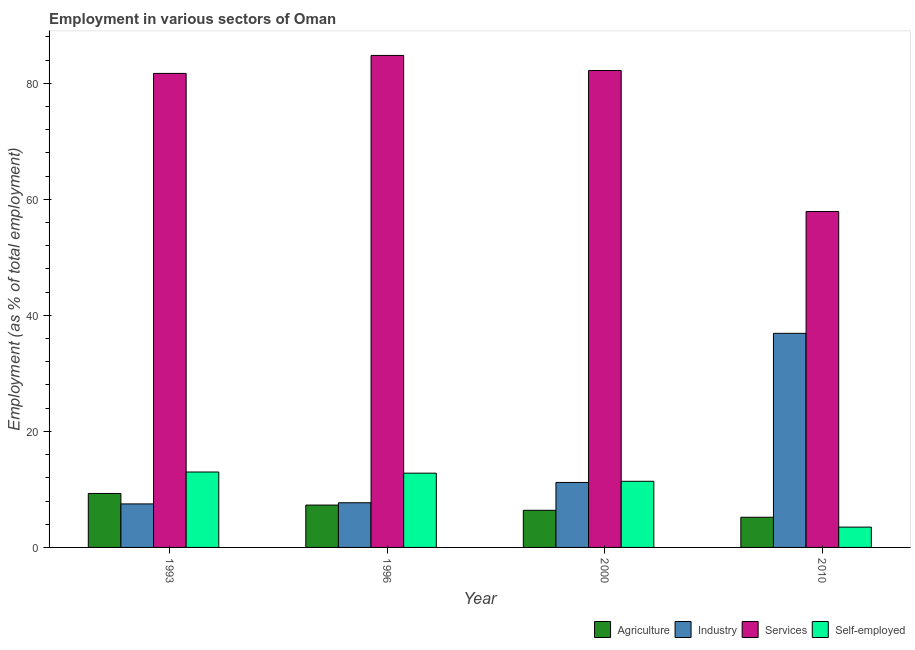Are the number of bars on each tick of the X-axis equal?
Offer a terse response. Yes. In how many cases, is the number of bars for a given year not equal to the number of legend labels?
Provide a succinct answer. 0. What is the percentage of self employed workers in 2010?
Ensure brevity in your answer.  3.5. Across all years, what is the minimum percentage of workers in agriculture?
Keep it short and to the point. 5.2. In which year was the percentage of self employed workers maximum?
Your answer should be very brief. 1993. What is the total percentage of workers in agriculture in the graph?
Give a very brief answer. 28.2. What is the difference between the percentage of workers in agriculture in 2000 and that in 2010?
Offer a terse response. 1.2. What is the difference between the percentage of workers in services in 2010 and the percentage of workers in agriculture in 2000?
Your response must be concise. -24.3. What is the average percentage of self employed workers per year?
Provide a succinct answer. 10.17. In how many years, is the percentage of self employed workers greater than 12 %?
Provide a succinct answer. 2. What is the ratio of the percentage of self employed workers in 1996 to that in 2000?
Give a very brief answer. 1.12. Is the percentage of workers in industry in 1996 less than that in 2000?
Your answer should be compact. Yes. Is the difference between the percentage of workers in agriculture in 1996 and 2000 greater than the difference between the percentage of workers in services in 1996 and 2000?
Offer a terse response. No. What is the difference between the highest and the second highest percentage of workers in services?
Offer a terse response. 2.6. What is the difference between the highest and the lowest percentage of self employed workers?
Give a very brief answer. 9.5. In how many years, is the percentage of workers in industry greater than the average percentage of workers in industry taken over all years?
Your answer should be compact. 1. Is the sum of the percentage of workers in industry in 1996 and 2000 greater than the maximum percentage of workers in agriculture across all years?
Offer a very short reply. No. Is it the case that in every year, the sum of the percentage of workers in agriculture and percentage of workers in services is greater than the sum of percentage of workers in industry and percentage of self employed workers?
Make the answer very short. No. What does the 3rd bar from the left in 2010 represents?
Provide a succinct answer. Services. What does the 4th bar from the right in 1993 represents?
Your answer should be compact. Agriculture. Does the graph contain grids?
Ensure brevity in your answer.  No. Where does the legend appear in the graph?
Make the answer very short. Bottom right. How many legend labels are there?
Ensure brevity in your answer.  4. How are the legend labels stacked?
Keep it short and to the point. Horizontal. What is the title of the graph?
Your answer should be compact. Employment in various sectors of Oman. What is the label or title of the X-axis?
Give a very brief answer. Year. What is the label or title of the Y-axis?
Keep it short and to the point. Employment (as % of total employment). What is the Employment (as % of total employment) of Agriculture in 1993?
Offer a very short reply. 9.3. What is the Employment (as % of total employment) in Industry in 1993?
Offer a terse response. 7.5. What is the Employment (as % of total employment) of Services in 1993?
Your response must be concise. 81.7. What is the Employment (as % of total employment) in Agriculture in 1996?
Your answer should be very brief. 7.3. What is the Employment (as % of total employment) of Industry in 1996?
Offer a terse response. 7.7. What is the Employment (as % of total employment) of Services in 1996?
Offer a very short reply. 84.8. What is the Employment (as % of total employment) in Self-employed in 1996?
Offer a very short reply. 12.8. What is the Employment (as % of total employment) in Agriculture in 2000?
Provide a short and direct response. 6.4. What is the Employment (as % of total employment) in Industry in 2000?
Offer a very short reply. 11.2. What is the Employment (as % of total employment) in Services in 2000?
Ensure brevity in your answer.  82.2. What is the Employment (as % of total employment) of Self-employed in 2000?
Give a very brief answer. 11.4. What is the Employment (as % of total employment) in Agriculture in 2010?
Offer a very short reply. 5.2. What is the Employment (as % of total employment) of Industry in 2010?
Provide a short and direct response. 36.9. What is the Employment (as % of total employment) in Services in 2010?
Provide a short and direct response. 57.9. Across all years, what is the maximum Employment (as % of total employment) in Agriculture?
Ensure brevity in your answer.  9.3. Across all years, what is the maximum Employment (as % of total employment) of Industry?
Provide a short and direct response. 36.9. Across all years, what is the maximum Employment (as % of total employment) of Services?
Provide a succinct answer. 84.8. Across all years, what is the maximum Employment (as % of total employment) in Self-employed?
Your response must be concise. 13. Across all years, what is the minimum Employment (as % of total employment) of Agriculture?
Keep it short and to the point. 5.2. Across all years, what is the minimum Employment (as % of total employment) in Industry?
Your answer should be compact. 7.5. Across all years, what is the minimum Employment (as % of total employment) of Services?
Offer a very short reply. 57.9. Across all years, what is the minimum Employment (as % of total employment) of Self-employed?
Offer a terse response. 3.5. What is the total Employment (as % of total employment) in Agriculture in the graph?
Ensure brevity in your answer.  28.2. What is the total Employment (as % of total employment) in Industry in the graph?
Make the answer very short. 63.3. What is the total Employment (as % of total employment) in Services in the graph?
Ensure brevity in your answer.  306.6. What is the total Employment (as % of total employment) in Self-employed in the graph?
Keep it short and to the point. 40.7. What is the difference between the Employment (as % of total employment) in Services in 1993 and that in 1996?
Offer a very short reply. -3.1. What is the difference between the Employment (as % of total employment) of Self-employed in 1993 and that in 1996?
Keep it short and to the point. 0.2. What is the difference between the Employment (as % of total employment) of Agriculture in 1993 and that in 2000?
Make the answer very short. 2.9. What is the difference between the Employment (as % of total employment) of Industry in 1993 and that in 2000?
Your answer should be compact. -3.7. What is the difference between the Employment (as % of total employment) in Services in 1993 and that in 2000?
Make the answer very short. -0.5. What is the difference between the Employment (as % of total employment) in Industry in 1993 and that in 2010?
Your answer should be compact. -29.4. What is the difference between the Employment (as % of total employment) of Services in 1993 and that in 2010?
Provide a short and direct response. 23.8. What is the difference between the Employment (as % of total employment) in Agriculture in 1996 and that in 2000?
Keep it short and to the point. 0.9. What is the difference between the Employment (as % of total employment) of Industry in 1996 and that in 2000?
Give a very brief answer. -3.5. What is the difference between the Employment (as % of total employment) of Industry in 1996 and that in 2010?
Ensure brevity in your answer.  -29.2. What is the difference between the Employment (as % of total employment) of Services in 1996 and that in 2010?
Offer a very short reply. 26.9. What is the difference between the Employment (as % of total employment) in Industry in 2000 and that in 2010?
Keep it short and to the point. -25.7. What is the difference between the Employment (as % of total employment) of Services in 2000 and that in 2010?
Ensure brevity in your answer.  24.3. What is the difference between the Employment (as % of total employment) in Agriculture in 1993 and the Employment (as % of total employment) in Industry in 1996?
Make the answer very short. 1.6. What is the difference between the Employment (as % of total employment) in Agriculture in 1993 and the Employment (as % of total employment) in Services in 1996?
Your answer should be very brief. -75.5. What is the difference between the Employment (as % of total employment) in Agriculture in 1993 and the Employment (as % of total employment) in Self-employed in 1996?
Your answer should be very brief. -3.5. What is the difference between the Employment (as % of total employment) of Industry in 1993 and the Employment (as % of total employment) of Services in 1996?
Provide a succinct answer. -77.3. What is the difference between the Employment (as % of total employment) in Services in 1993 and the Employment (as % of total employment) in Self-employed in 1996?
Provide a succinct answer. 68.9. What is the difference between the Employment (as % of total employment) in Agriculture in 1993 and the Employment (as % of total employment) in Services in 2000?
Your answer should be compact. -72.9. What is the difference between the Employment (as % of total employment) of Industry in 1993 and the Employment (as % of total employment) of Services in 2000?
Keep it short and to the point. -74.7. What is the difference between the Employment (as % of total employment) of Services in 1993 and the Employment (as % of total employment) of Self-employed in 2000?
Provide a succinct answer. 70.3. What is the difference between the Employment (as % of total employment) of Agriculture in 1993 and the Employment (as % of total employment) of Industry in 2010?
Provide a short and direct response. -27.6. What is the difference between the Employment (as % of total employment) of Agriculture in 1993 and the Employment (as % of total employment) of Services in 2010?
Your answer should be compact. -48.6. What is the difference between the Employment (as % of total employment) of Industry in 1993 and the Employment (as % of total employment) of Services in 2010?
Your response must be concise. -50.4. What is the difference between the Employment (as % of total employment) of Services in 1993 and the Employment (as % of total employment) of Self-employed in 2010?
Provide a short and direct response. 78.2. What is the difference between the Employment (as % of total employment) of Agriculture in 1996 and the Employment (as % of total employment) of Services in 2000?
Give a very brief answer. -74.9. What is the difference between the Employment (as % of total employment) in Agriculture in 1996 and the Employment (as % of total employment) in Self-employed in 2000?
Your answer should be very brief. -4.1. What is the difference between the Employment (as % of total employment) of Industry in 1996 and the Employment (as % of total employment) of Services in 2000?
Offer a terse response. -74.5. What is the difference between the Employment (as % of total employment) in Industry in 1996 and the Employment (as % of total employment) in Self-employed in 2000?
Ensure brevity in your answer.  -3.7. What is the difference between the Employment (as % of total employment) in Services in 1996 and the Employment (as % of total employment) in Self-employed in 2000?
Provide a short and direct response. 73.4. What is the difference between the Employment (as % of total employment) of Agriculture in 1996 and the Employment (as % of total employment) of Industry in 2010?
Your answer should be very brief. -29.6. What is the difference between the Employment (as % of total employment) of Agriculture in 1996 and the Employment (as % of total employment) of Services in 2010?
Your answer should be compact. -50.6. What is the difference between the Employment (as % of total employment) of Industry in 1996 and the Employment (as % of total employment) of Services in 2010?
Your answer should be compact. -50.2. What is the difference between the Employment (as % of total employment) of Industry in 1996 and the Employment (as % of total employment) of Self-employed in 2010?
Offer a very short reply. 4.2. What is the difference between the Employment (as % of total employment) of Services in 1996 and the Employment (as % of total employment) of Self-employed in 2010?
Provide a short and direct response. 81.3. What is the difference between the Employment (as % of total employment) of Agriculture in 2000 and the Employment (as % of total employment) of Industry in 2010?
Provide a succinct answer. -30.5. What is the difference between the Employment (as % of total employment) of Agriculture in 2000 and the Employment (as % of total employment) of Services in 2010?
Your response must be concise. -51.5. What is the difference between the Employment (as % of total employment) of Agriculture in 2000 and the Employment (as % of total employment) of Self-employed in 2010?
Your answer should be very brief. 2.9. What is the difference between the Employment (as % of total employment) of Industry in 2000 and the Employment (as % of total employment) of Services in 2010?
Make the answer very short. -46.7. What is the difference between the Employment (as % of total employment) in Services in 2000 and the Employment (as % of total employment) in Self-employed in 2010?
Keep it short and to the point. 78.7. What is the average Employment (as % of total employment) of Agriculture per year?
Offer a terse response. 7.05. What is the average Employment (as % of total employment) in Industry per year?
Provide a succinct answer. 15.82. What is the average Employment (as % of total employment) of Services per year?
Keep it short and to the point. 76.65. What is the average Employment (as % of total employment) in Self-employed per year?
Provide a short and direct response. 10.18. In the year 1993, what is the difference between the Employment (as % of total employment) in Agriculture and Employment (as % of total employment) in Services?
Offer a terse response. -72.4. In the year 1993, what is the difference between the Employment (as % of total employment) of Industry and Employment (as % of total employment) of Services?
Provide a succinct answer. -74.2. In the year 1993, what is the difference between the Employment (as % of total employment) in Industry and Employment (as % of total employment) in Self-employed?
Your response must be concise. -5.5. In the year 1993, what is the difference between the Employment (as % of total employment) of Services and Employment (as % of total employment) of Self-employed?
Provide a succinct answer. 68.7. In the year 1996, what is the difference between the Employment (as % of total employment) of Agriculture and Employment (as % of total employment) of Industry?
Provide a succinct answer. -0.4. In the year 1996, what is the difference between the Employment (as % of total employment) of Agriculture and Employment (as % of total employment) of Services?
Provide a succinct answer. -77.5. In the year 1996, what is the difference between the Employment (as % of total employment) in Industry and Employment (as % of total employment) in Services?
Your answer should be very brief. -77.1. In the year 1996, what is the difference between the Employment (as % of total employment) in Industry and Employment (as % of total employment) in Self-employed?
Give a very brief answer. -5.1. In the year 2000, what is the difference between the Employment (as % of total employment) of Agriculture and Employment (as % of total employment) of Services?
Ensure brevity in your answer.  -75.8. In the year 2000, what is the difference between the Employment (as % of total employment) in Agriculture and Employment (as % of total employment) in Self-employed?
Offer a terse response. -5. In the year 2000, what is the difference between the Employment (as % of total employment) in Industry and Employment (as % of total employment) in Services?
Make the answer very short. -71. In the year 2000, what is the difference between the Employment (as % of total employment) in Industry and Employment (as % of total employment) in Self-employed?
Offer a terse response. -0.2. In the year 2000, what is the difference between the Employment (as % of total employment) of Services and Employment (as % of total employment) of Self-employed?
Make the answer very short. 70.8. In the year 2010, what is the difference between the Employment (as % of total employment) in Agriculture and Employment (as % of total employment) in Industry?
Offer a very short reply. -31.7. In the year 2010, what is the difference between the Employment (as % of total employment) in Agriculture and Employment (as % of total employment) in Services?
Offer a terse response. -52.7. In the year 2010, what is the difference between the Employment (as % of total employment) of Agriculture and Employment (as % of total employment) of Self-employed?
Make the answer very short. 1.7. In the year 2010, what is the difference between the Employment (as % of total employment) in Industry and Employment (as % of total employment) in Services?
Keep it short and to the point. -21. In the year 2010, what is the difference between the Employment (as % of total employment) of Industry and Employment (as % of total employment) of Self-employed?
Give a very brief answer. 33.4. In the year 2010, what is the difference between the Employment (as % of total employment) of Services and Employment (as % of total employment) of Self-employed?
Ensure brevity in your answer.  54.4. What is the ratio of the Employment (as % of total employment) in Agriculture in 1993 to that in 1996?
Make the answer very short. 1.27. What is the ratio of the Employment (as % of total employment) of Services in 1993 to that in 1996?
Offer a terse response. 0.96. What is the ratio of the Employment (as % of total employment) in Self-employed in 1993 to that in 1996?
Your answer should be compact. 1.02. What is the ratio of the Employment (as % of total employment) in Agriculture in 1993 to that in 2000?
Your answer should be very brief. 1.45. What is the ratio of the Employment (as % of total employment) in Industry in 1993 to that in 2000?
Ensure brevity in your answer.  0.67. What is the ratio of the Employment (as % of total employment) in Services in 1993 to that in 2000?
Your response must be concise. 0.99. What is the ratio of the Employment (as % of total employment) in Self-employed in 1993 to that in 2000?
Offer a very short reply. 1.14. What is the ratio of the Employment (as % of total employment) of Agriculture in 1993 to that in 2010?
Provide a succinct answer. 1.79. What is the ratio of the Employment (as % of total employment) in Industry in 1993 to that in 2010?
Ensure brevity in your answer.  0.2. What is the ratio of the Employment (as % of total employment) of Services in 1993 to that in 2010?
Ensure brevity in your answer.  1.41. What is the ratio of the Employment (as % of total employment) in Self-employed in 1993 to that in 2010?
Your answer should be compact. 3.71. What is the ratio of the Employment (as % of total employment) in Agriculture in 1996 to that in 2000?
Provide a short and direct response. 1.14. What is the ratio of the Employment (as % of total employment) of Industry in 1996 to that in 2000?
Your answer should be compact. 0.69. What is the ratio of the Employment (as % of total employment) of Services in 1996 to that in 2000?
Provide a short and direct response. 1.03. What is the ratio of the Employment (as % of total employment) in Self-employed in 1996 to that in 2000?
Offer a very short reply. 1.12. What is the ratio of the Employment (as % of total employment) in Agriculture in 1996 to that in 2010?
Offer a terse response. 1.4. What is the ratio of the Employment (as % of total employment) in Industry in 1996 to that in 2010?
Your answer should be very brief. 0.21. What is the ratio of the Employment (as % of total employment) in Services in 1996 to that in 2010?
Your response must be concise. 1.46. What is the ratio of the Employment (as % of total employment) in Self-employed in 1996 to that in 2010?
Your answer should be very brief. 3.66. What is the ratio of the Employment (as % of total employment) in Agriculture in 2000 to that in 2010?
Ensure brevity in your answer.  1.23. What is the ratio of the Employment (as % of total employment) in Industry in 2000 to that in 2010?
Make the answer very short. 0.3. What is the ratio of the Employment (as % of total employment) in Services in 2000 to that in 2010?
Make the answer very short. 1.42. What is the ratio of the Employment (as % of total employment) of Self-employed in 2000 to that in 2010?
Offer a very short reply. 3.26. What is the difference between the highest and the second highest Employment (as % of total employment) in Industry?
Provide a succinct answer. 25.7. What is the difference between the highest and the second highest Employment (as % of total employment) of Services?
Your answer should be compact. 2.6. What is the difference between the highest and the lowest Employment (as % of total employment) of Industry?
Provide a short and direct response. 29.4. What is the difference between the highest and the lowest Employment (as % of total employment) of Services?
Offer a terse response. 26.9. 